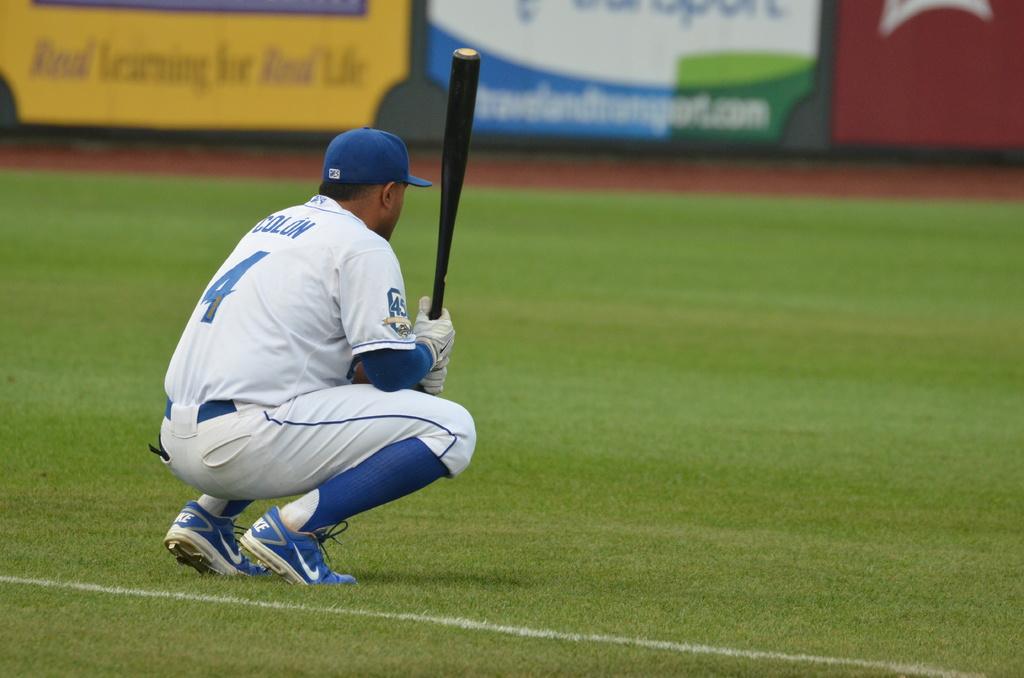What is the name on the player's jersey?
Your answer should be compact. Colon. What is the number on the player's jersey?
Offer a very short reply. 4. 